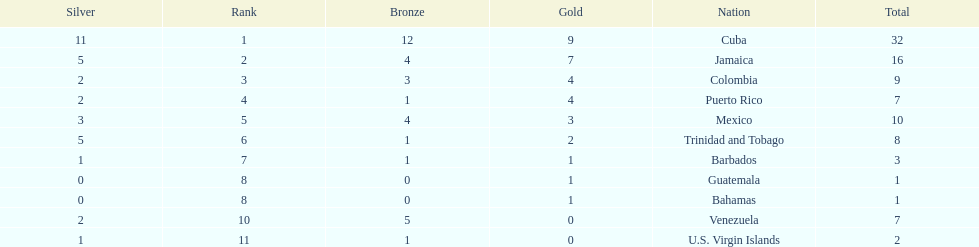What is the difference in medals between cuba and mexico? 22. 